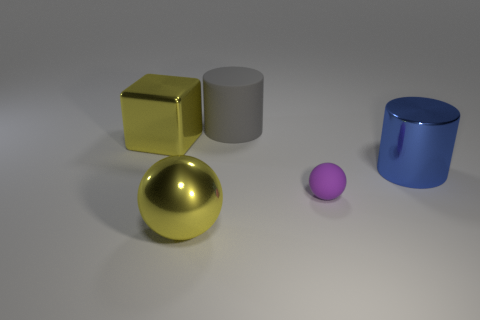What number of things are tiny brown things or matte spheres?
Your answer should be very brief. 1. Is the material of the yellow object that is behind the large blue thing the same as the big gray cylinder?
Provide a succinct answer. No. What number of objects are either things right of the purple ball or yellow shiny things?
Keep it short and to the point. 3. The large object that is the same material as the small purple thing is what color?
Keep it short and to the point. Gray. Are there any rubber spheres of the same size as the gray rubber cylinder?
Provide a succinct answer. No. There is a big metallic object in front of the purple object; is its color the same as the large cube?
Keep it short and to the point. Yes. There is a big metallic object that is to the left of the big gray rubber cylinder and in front of the big cube; what color is it?
Offer a very short reply. Yellow. There is a gray object that is the same size as the blue shiny thing; what is its shape?
Keep it short and to the point. Cylinder. Are there any red shiny things of the same shape as the big matte thing?
Offer a terse response. No. There is a metallic object that is right of the yellow metal ball; is its size the same as the tiny matte thing?
Keep it short and to the point. No. 